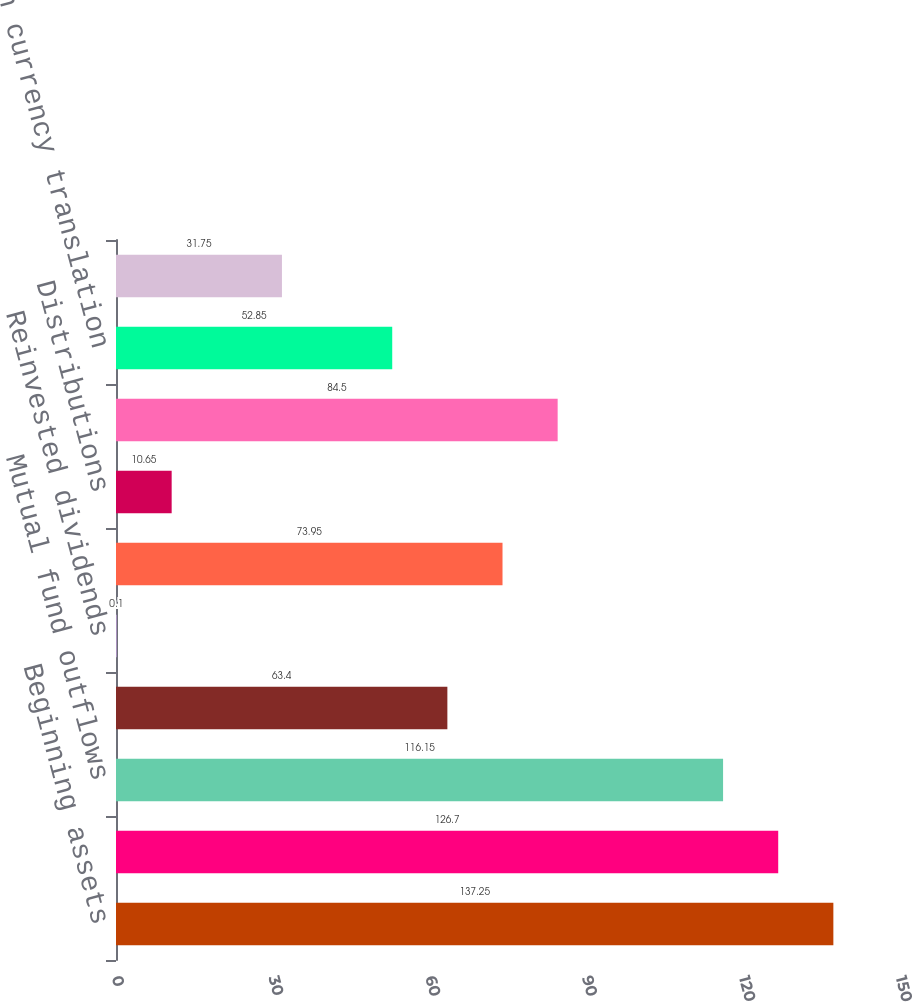<chart> <loc_0><loc_0><loc_500><loc_500><bar_chart><fcel>Beginning assets<fcel>Mutual fund inflows<fcel>Mutual fund outflows<fcel>Net new flows<fcel>Reinvested dividends<fcel>Net flows<fcel>Distributions<fcel>Market appreciation<fcel>Foreign currency translation<fcel>Other<nl><fcel>137.25<fcel>126.7<fcel>116.15<fcel>63.4<fcel>0.1<fcel>73.95<fcel>10.65<fcel>84.5<fcel>52.85<fcel>31.75<nl></chart> 